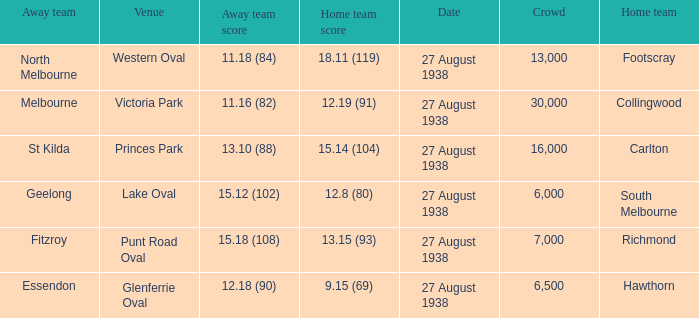Which away team scored 12.18 (90)? Essendon. 